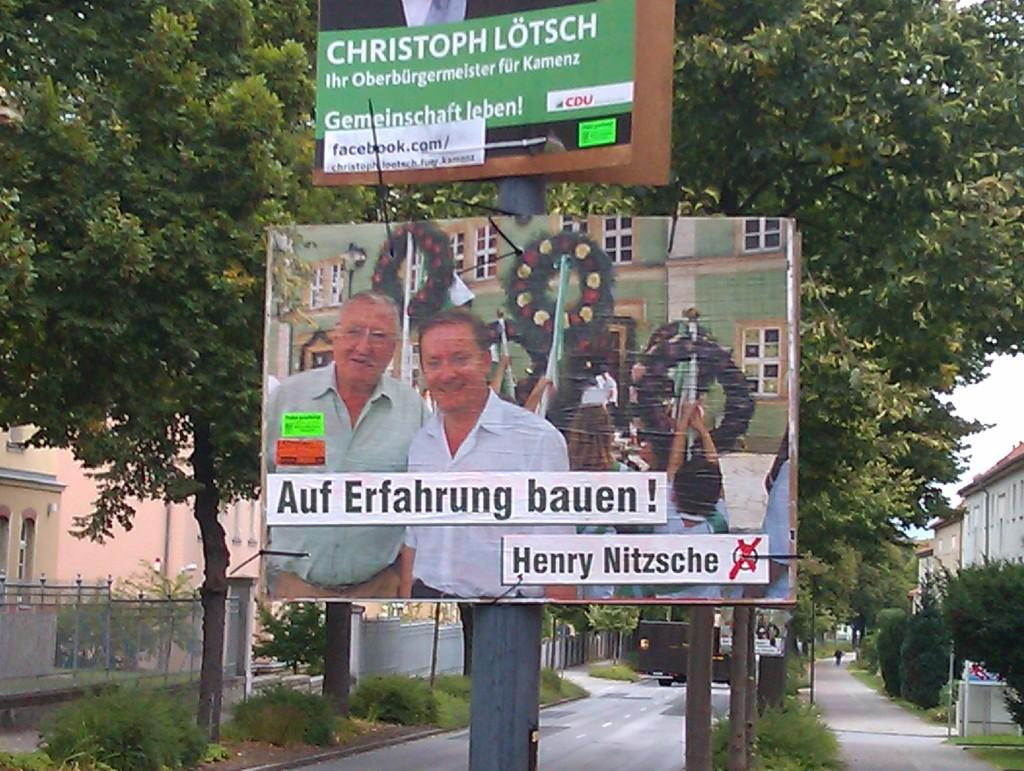Provide a one-sentence caption for the provided image. A large poster for Christoph Lotsch sits on a pole in front of trees. 